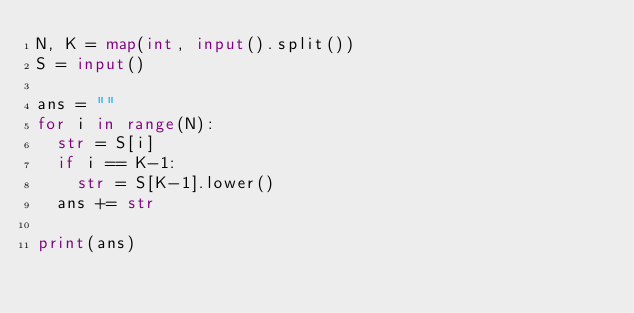Convert code to text. <code><loc_0><loc_0><loc_500><loc_500><_Python_>N, K = map(int, input().split())
S = input()

ans = ""
for i in range(N):
  str = S[i]
  if i == K-1:
    str = S[K-1].lower()
  ans += str
  
print(ans)</code> 